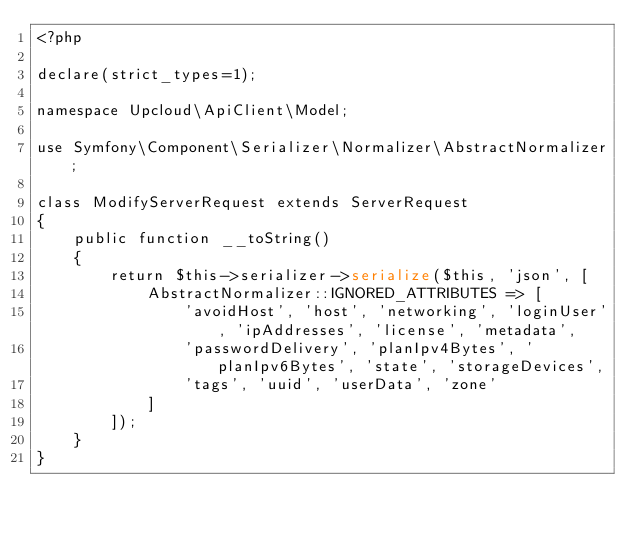<code> <loc_0><loc_0><loc_500><loc_500><_PHP_><?php

declare(strict_types=1);

namespace Upcloud\ApiClient\Model;

use Symfony\Component\Serializer\Normalizer\AbstractNormalizer;

class ModifyServerRequest extends ServerRequest
{
    public function __toString()
    {
        return $this->serializer->serialize($this, 'json', [
            AbstractNormalizer::IGNORED_ATTRIBUTES => [
                'avoidHost', 'host', 'networking', 'loginUser', 'ipAddresses', 'license', 'metadata',
                'passwordDelivery', 'planIpv4Bytes', 'planIpv6Bytes', 'state', 'storageDevices',
                'tags', 'uuid', 'userData', 'zone'
            ]
        ]);
    }
}


</code> 